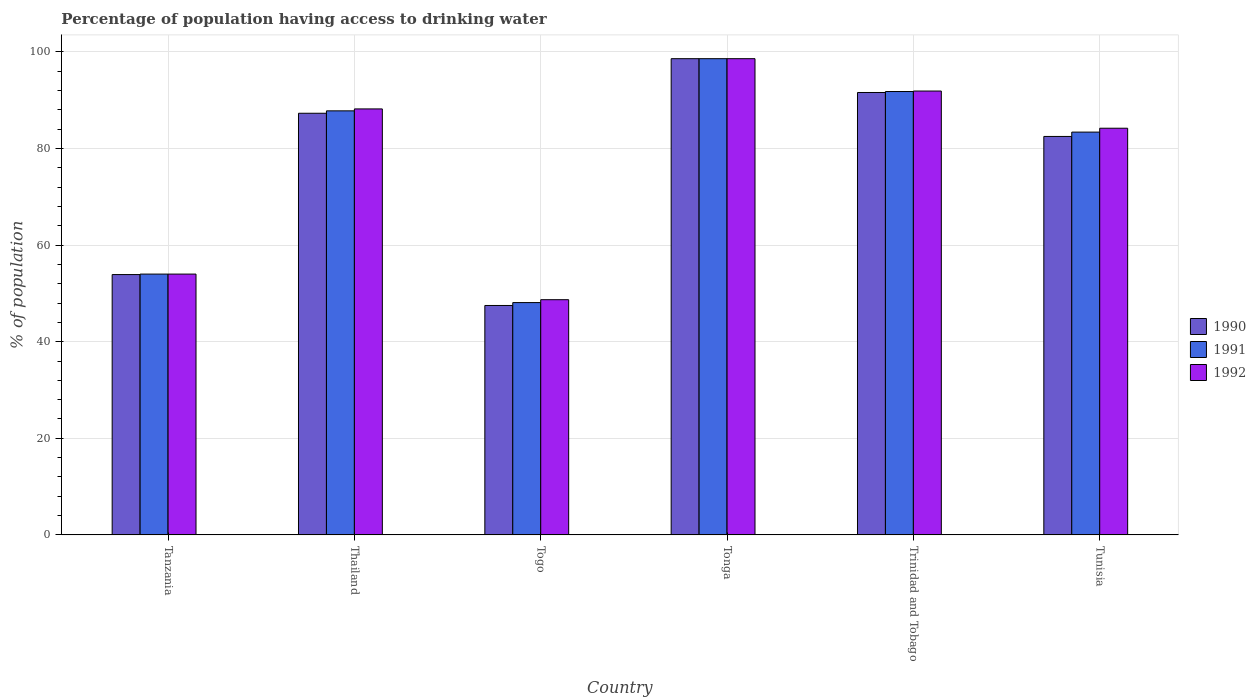How many different coloured bars are there?
Ensure brevity in your answer.  3. Are the number of bars per tick equal to the number of legend labels?
Ensure brevity in your answer.  Yes. Are the number of bars on each tick of the X-axis equal?
Offer a terse response. Yes. How many bars are there on the 2nd tick from the left?
Provide a succinct answer. 3. What is the label of the 3rd group of bars from the left?
Your answer should be compact. Togo. What is the percentage of population having access to drinking water in 1990 in Tanzania?
Provide a succinct answer. 53.9. Across all countries, what is the maximum percentage of population having access to drinking water in 1990?
Keep it short and to the point. 98.6. Across all countries, what is the minimum percentage of population having access to drinking water in 1991?
Provide a short and direct response. 48.1. In which country was the percentage of population having access to drinking water in 1991 maximum?
Make the answer very short. Tonga. In which country was the percentage of population having access to drinking water in 1992 minimum?
Make the answer very short. Togo. What is the total percentage of population having access to drinking water in 1992 in the graph?
Your answer should be very brief. 465.6. What is the difference between the percentage of population having access to drinking water in 1990 in Tanzania and that in Tunisia?
Ensure brevity in your answer.  -28.6. What is the difference between the percentage of population having access to drinking water in 1992 in Trinidad and Tobago and the percentage of population having access to drinking water in 1991 in Togo?
Offer a very short reply. 43.8. What is the average percentage of population having access to drinking water in 1990 per country?
Keep it short and to the point. 76.9. What is the difference between the percentage of population having access to drinking water of/in 1990 and percentage of population having access to drinking water of/in 1992 in Thailand?
Keep it short and to the point. -0.9. What is the ratio of the percentage of population having access to drinking water in 1992 in Trinidad and Tobago to that in Tunisia?
Your answer should be compact. 1.09. Is the percentage of population having access to drinking water in 1990 in Togo less than that in Tonga?
Give a very brief answer. Yes. What is the difference between the highest and the second highest percentage of population having access to drinking water in 1992?
Ensure brevity in your answer.  -10.4. What is the difference between the highest and the lowest percentage of population having access to drinking water in 1992?
Your response must be concise. 49.9. Is it the case that in every country, the sum of the percentage of population having access to drinking water in 1991 and percentage of population having access to drinking water in 1990 is greater than the percentage of population having access to drinking water in 1992?
Your answer should be compact. Yes. How many bars are there?
Provide a short and direct response. 18. Are all the bars in the graph horizontal?
Your answer should be compact. No. How many countries are there in the graph?
Your answer should be very brief. 6. Does the graph contain any zero values?
Provide a short and direct response. No. Where does the legend appear in the graph?
Your answer should be compact. Center right. How are the legend labels stacked?
Offer a terse response. Vertical. What is the title of the graph?
Offer a terse response. Percentage of population having access to drinking water. Does "1974" appear as one of the legend labels in the graph?
Your answer should be compact. No. What is the label or title of the X-axis?
Offer a very short reply. Country. What is the label or title of the Y-axis?
Keep it short and to the point. % of population. What is the % of population of 1990 in Tanzania?
Offer a terse response. 53.9. What is the % of population in 1990 in Thailand?
Provide a short and direct response. 87.3. What is the % of population of 1991 in Thailand?
Provide a short and direct response. 87.8. What is the % of population of 1992 in Thailand?
Ensure brevity in your answer.  88.2. What is the % of population in 1990 in Togo?
Your response must be concise. 47.5. What is the % of population of 1991 in Togo?
Make the answer very short. 48.1. What is the % of population of 1992 in Togo?
Offer a terse response. 48.7. What is the % of population in 1990 in Tonga?
Provide a succinct answer. 98.6. What is the % of population of 1991 in Tonga?
Offer a terse response. 98.6. What is the % of population of 1992 in Tonga?
Your answer should be compact. 98.6. What is the % of population of 1990 in Trinidad and Tobago?
Offer a terse response. 91.6. What is the % of population of 1991 in Trinidad and Tobago?
Give a very brief answer. 91.8. What is the % of population in 1992 in Trinidad and Tobago?
Your response must be concise. 91.9. What is the % of population of 1990 in Tunisia?
Ensure brevity in your answer.  82.5. What is the % of population in 1991 in Tunisia?
Your response must be concise. 83.4. What is the % of population in 1992 in Tunisia?
Your response must be concise. 84.2. Across all countries, what is the maximum % of population in 1990?
Provide a short and direct response. 98.6. Across all countries, what is the maximum % of population in 1991?
Make the answer very short. 98.6. Across all countries, what is the maximum % of population in 1992?
Ensure brevity in your answer.  98.6. Across all countries, what is the minimum % of population of 1990?
Your response must be concise. 47.5. Across all countries, what is the minimum % of population in 1991?
Keep it short and to the point. 48.1. Across all countries, what is the minimum % of population of 1992?
Keep it short and to the point. 48.7. What is the total % of population in 1990 in the graph?
Offer a very short reply. 461.4. What is the total % of population of 1991 in the graph?
Offer a very short reply. 463.7. What is the total % of population in 1992 in the graph?
Your answer should be compact. 465.6. What is the difference between the % of population in 1990 in Tanzania and that in Thailand?
Provide a short and direct response. -33.4. What is the difference between the % of population of 1991 in Tanzania and that in Thailand?
Your response must be concise. -33.8. What is the difference between the % of population of 1992 in Tanzania and that in Thailand?
Keep it short and to the point. -34.2. What is the difference between the % of population of 1990 in Tanzania and that in Togo?
Your answer should be very brief. 6.4. What is the difference between the % of population in 1991 in Tanzania and that in Togo?
Keep it short and to the point. 5.9. What is the difference between the % of population in 1992 in Tanzania and that in Togo?
Your answer should be very brief. 5.3. What is the difference between the % of population of 1990 in Tanzania and that in Tonga?
Offer a terse response. -44.7. What is the difference between the % of population of 1991 in Tanzania and that in Tonga?
Give a very brief answer. -44.6. What is the difference between the % of population of 1992 in Tanzania and that in Tonga?
Make the answer very short. -44.6. What is the difference between the % of population in 1990 in Tanzania and that in Trinidad and Tobago?
Your answer should be very brief. -37.7. What is the difference between the % of population in 1991 in Tanzania and that in Trinidad and Tobago?
Provide a short and direct response. -37.8. What is the difference between the % of population of 1992 in Tanzania and that in Trinidad and Tobago?
Make the answer very short. -37.9. What is the difference between the % of population of 1990 in Tanzania and that in Tunisia?
Ensure brevity in your answer.  -28.6. What is the difference between the % of population in 1991 in Tanzania and that in Tunisia?
Keep it short and to the point. -29.4. What is the difference between the % of population in 1992 in Tanzania and that in Tunisia?
Your answer should be compact. -30.2. What is the difference between the % of population in 1990 in Thailand and that in Togo?
Provide a succinct answer. 39.8. What is the difference between the % of population of 1991 in Thailand and that in Togo?
Give a very brief answer. 39.7. What is the difference between the % of population in 1992 in Thailand and that in Togo?
Your answer should be compact. 39.5. What is the difference between the % of population of 1990 in Thailand and that in Tonga?
Your answer should be very brief. -11.3. What is the difference between the % of population in 1991 in Thailand and that in Tonga?
Your answer should be compact. -10.8. What is the difference between the % of population in 1991 in Thailand and that in Trinidad and Tobago?
Provide a short and direct response. -4. What is the difference between the % of population in 1992 in Thailand and that in Trinidad and Tobago?
Keep it short and to the point. -3.7. What is the difference between the % of population of 1991 in Thailand and that in Tunisia?
Your response must be concise. 4.4. What is the difference between the % of population in 1992 in Thailand and that in Tunisia?
Make the answer very short. 4. What is the difference between the % of population of 1990 in Togo and that in Tonga?
Offer a very short reply. -51.1. What is the difference between the % of population of 1991 in Togo and that in Tonga?
Ensure brevity in your answer.  -50.5. What is the difference between the % of population in 1992 in Togo and that in Tonga?
Your response must be concise. -49.9. What is the difference between the % of population in 1990 in Togo and that in Trinidad and Tobago?
Provide a succinct answer. -44.1. What is the difference between the % of population of 1991 in Togo and that in Trinidad and Tobago?
Your response must be concise. -43.7. What is the difference between the % of population of 1992 in Togo and that in Trinidad and Tobago?
Your response must be concise. -43.2. What is the difference between the % of population of 1990 in Togo and that in Tunisia?
Your answer should be very brief. -35. What is the difference between the % of population in 1991 in Togo and that in Tunisia?
Provide a short and direct response. -35.3. What is the difference between the % of population in 1992 in Togo and that in Tunisia?
Keep it short and to the point. -35.5. What is the difference between the % of population of 1992 in Tonga and that in Tunisia?
Offer a very short reply. 14.4. What is the difference between the % of population of 1991 in Trinidad and Tobago and that in Tunisia?
Offer a terse response. 8.4. What is the difference between the % of population of 1992 in Trinidad and Tobago and that in Tunisia?
Your answer should be compact. 7.7. What is the difference between the % of population of 1990 in Tanzania and the % of population of 1991 in Thailand?
Your answer should be compact. -33.9. What is the difference between the % of population of 1990 in Tanzania and the % of population of 1992 in Thailand?
Give a very brief answer. -34.3. What is the difference between the % of population of 1991 in Tanzania and the % of population of 1992 in Thailand?
Offer a very short reply. -34.2. What is the difference between the % of population of 1991 in Tanzania and the % of population of 1992 in Togo?
Provide a succinct answer. 5.3. What is the difference between the % of population of 1990 in Tanzania and the % of population of 1991 in Tonga?
Offer a very short reply. -44.7. What is the difference between the % of population of 1990 in Tanzania and the % of population of 1992 in Tonga?
Your answer should be very brief. -44.7. What is the difference between the % of population in 1991 in Tanzania and the % of population in 1992 in Tonga?
Keep it short and to the point. -44.6. What is the difference between the % of population of 1990 in Tanzania and the % of population of 1991 in Trinidad and Tobago?
Give a very brief answer. -37.9. What is the difference between the % of population of 1990 in Tanzania and the % of population of 1992 in Trinidad and Tobago?
Ensure brevity in your answer.  -38. What is the difference between the % of population of 1991 in Tanzania and the % of population of 1992 in Trinidad and Tobago?
Make the answer very short. -37.9. What is the difference between the % of population of 1990 in Tanzania and the % of population of 1991 in Tunisia?
Provide a succinct answer. -29.5. What is the difference between the % of population of 1990 in Tanzania and the % of population of 1992 in Tunisia?
Ensure brevity in your answer.  -30.3. What is the difference between the % of population in 1991 in Tanzania and the % of population in 1992 in Tunisia?
Keep it short and to the point. -30.2. What is the difference between the % of population in 1990 in Thailand and the % of population in 1991 in Togo?
Provide a short and direct response. 39.2. What is the difference between the % of population in 1990 in Thailand and the % of population in 1992 in Togo?
Make the answer very short. 38.6. What is the difference between the % of population of 1991 in Thailand and the % of population of 1992 in Togo?
Provide a short and direct response. 39.1. What is the difference between the % of population of 1990 in Thailand and the % of population of 1991 in Trinidad and Tobago?
Offer a terse response. -4.5. What is the difference between the % of population of 1991 in Thailand and the % of population of 1992 in Trinidad and Tobago?
Your response must be concise. -4.1. What is the difference between the % of population of 1990 in Togo and the % of population of 1991 in Tonga?
Your response must be concise. -51.1. What is the difference between the % of population in 1990 in Togo and the % of population in 1992 in Tonga?
Provide a succinct answer. -51.1. What is the difference between the % of population of 1991 in Togo and the % of population of 1992 in Tonga?
Provide a short and direct response. -50.5. What is the difference between the % of population of 1990 in Togo and the % of population of 1991 in Trinidad and Tobago?
Make the answer very short. -44.3. What is the difference between the % of population in 1990 in Togo and the % of population in 1992 in Trinidad and Tobago?
Your response must be concise. -44.4. What is the difference between the % of population of 1991 in Togo and the % of population of 1992 in Trinidad and Tobago?
Give a very brief answer. -43.8. What is the difference between the % of population in 1990 in Togo and the % of population in 1991 in Tunisia?
Your answer should be very brief. -35.9. What is the difference between the % of population in 1990 in Togo and the % of population in 1992 in Tunisia?
Your response must be concise. -36.7. What is the difference between the % of population of 1991 in Togo and the % of population of 1992 in Tunisia?
Keep it short and to the point. -36.1. What is the difference between the % of population in 1990 in Tonga and the % of population in 1992 in Trinidad and Tobago?
Offer a very short reply. 6.7. What is the difference between the % of population in 1991 in Tonga and the % of population in 1992 in Trinidad and Tobago?
Give a very brief answer. 6.7. What is the difference between the % of population in 1990 in Tonga and the % of population in 1991 in Tunisia?
Your answer should be very brief. 15.2. What is the difference between the % of population in 1990 in Tonga and the % of population in 1992 in Tunisia?
Provide a short and direct response. 14.4. What is the difference between the % of population of 1991 in Tonga and the % of population of 1992 in Tunisia?
Offer a terse response. 14.4. What is the difference between the % of population of 1990 in Trinidad and Tobago and the % of population of 1991 in Tunisia?
Give a very brief answer. 8.2. What is the average % of population in 1990 per country?
Ensure brevity in your answer.  76.9. What is the average % of population of 1991 per country?
Keep it short and to the point. 77.28. What is the average % of population in 1992 per country?
Ensure brevity in your answer.  77.6. What is the difference between the % of population of 1991 and % of population of 1992 in Tanzania?
Make the answer very short. 0. What is the difference between the % of population of 1990 and % of population of 1991 in Thailand?
Your answer should be compact. -0.5. What is the difference between the % of population in 1990 and % of population in 1992 in Thailand?
Your answer should be compact. -0.9. What is the difference between the % of population in 1990 and % of population in 1992 in Togo?
Make the answer very short. -1.2. What is the difference between the % of population of 1990 and % of population of 1992 in Tonga?
Offer a terse response. 0. What is the difference between the % of population in 1990 and % of population in 1991 in Trinidad and Tobago?
Your answer should be compact. -0.2. What is the difference between the % of population of 1991 and % of population of 1992 in Trinidad and Tobago?
Make the answer very short. -0.1. What is the difference between the % of population of 1990 and % of population of 1991 in Tunisia?
Your answer should be compact. -0.9. What is the difference between the % of population of 1990 and % of population of 1992 in Tunisia?
Give a very brief answer. -1.7. What is the difference between the % of population in 1991 and % of population in 1992 in Tunisia?
Keep it short and to the point. -0.8. What is the ratio of the % of population in 1990 in Tanzania to that in Thailand?
Provide a short and direct response. 0.62. What is the ratio of the % of population in 1991 in Tanzania to that in Thailand?
Offer a terse response. 0.61. What is the ratio of the % of population in 1992 in Tanzania to that in Thailand?
Keep it short and to the point. 0.61. What is the ratio of the % of population in 1990 in Tanzania to that in Togo?
Your answer should be compact. 1.13. What is the ratio of the % of population of 1991 in Tanzania to that in Togo?
Provide a succinct answer. 1.12. What is the ratio of the % of population in 1992 in Tanzania to that in Togo?
Make the answer very short. 1.11. What is the ratio of the % of population in 1990 in Tanzania to that in Tonga?
Ensure brevity in your answer.  0.55. What is the ratio of the % of population of 1991 in Tanzania to that in Tonga?
Keep it short and to the point. 0.55. What is the ratio of the % of population of 1992 in Tanzania to that in Tonga?
Provide a succinct answer. 0.55. What is the ratio of the % of population in 1990 in Tanzania to that in Trinidad and Tobago?
Keep it short and to the point. 0.59. What is the ratio of the % of population of 1991 in Tanzania to that in Trinidad and Tobago?
Offer a terse response. 0.59. What is the ratio of the % of population in 1992 in Tanzania to that in Trinidad and Tobago?
Your answer should be compact. 0.59. What is the ratio of the % of population of 1990 in Tanzania to that in Tunisia?
Ensure brevity in your answer.  0.65. What is the ratio of the % of population in 1991 in Tanzania to that in Tunisia?
Offer a terse response. 0.65. What is the ratio of the % of population of 1992 in Tanzania to that in Tunisia?
Provide a succinct answer. 0.64. What is the ratio of the % of population of 1990 in Thailand to that in Togo?
Provide a succinct answer. 1.84. What is the ratio of the % of population in 1991 in Thailand to that in Togo?
Give a very brief answer. 1.83. What is the ratio of the % of population of 1992 in Thailand to that in Togo?
Offer a very short reply. 1.81. What is the ratio of the % of population of 1990 in Thailand to that in Tonga?
Provide a short and direct response. 0.89. What is the ratio of the % of population of 1991 in Thailand to that in Tonga?
Keep it short and to the point. 0.89. What is the ratio of the % of population in 1992 in Thailand to that in Tonga?
Keep it short and to the point. 0.89. What is the ratio of the % of population in 1990 in Thailand to that in Trinidad and Tobago?
Your answer should be very brief. 0.95. What is the ratio of the % of population in 1991 in Thailand to that in Trinidad and Tobago?
Give a very brief answer. 0.96. What is the ratio of the % of population of 1992 in Thailand to that in Trinidad and Tobago?
Ensure brevity in your answer.  0.96. What is the ratio of the % of population in 1990 in Thailand to that in Tunisia?
Ensure brevity in your answer.  1.06. What is the ratio of the % of population in 1991 in Thailand to that in Tunisia?
Make the answer very short. 1.05. What is the ratio of the % of population in 1992 in Thailand to that in Tunisia?
Provide a short and direct response. 1.05. What is the ratio of the % of population of 1990 in Togo to that in Tonga?
Offer a very short reply. 0.48. What is the ratio of the % of population of 1991 in Togo to that in Tonga?
Make the answer very short. 0.49. What is the ratio of the % of population of 1992 in Togo to that in Tonga?
Your answer should be very brief. 0.49. What is the ratio of the % of population in 1990 in Togo to that in Trinidad and Tobago?
Your answer should be compact. 0.52. What is the ratio of the % of population of 1991 in Togo to that in Trinidad and Tobago?
Your answer should be very brief. 0.52. What is the ratio of the % of population in 1992 in Togo to that in Trinidad and Tobago?
Make the answer very short. 0.53. What is the ratio of the % of population of 1990 in Togo to that in Tunisia?
Provide a succinct answer. 0.58. What is the ratio of the % of population of 1991 in Togo to that in Tunisia?
Keep it short and to the point. 0.58. What is the ratio of the % of population of 1992 in Togo to that in Tunisia?
Offer a terse response. 0.58. What is the ratio of the % of population in 1990 in Tonga to that in Trinidad and Tobago?
Ensure brevity in your answer.  1.08. What is the ratio of the % of population in 1991 in Tonga to that in Trinidad and Tobago?
Your answer should be very brief. 1.07. What is the ratio of the % of population in 1992 in Tonga to that in Trinidad and Tobago?
Your answer should be very brief. 1.07. What is the ratio of the % of population of 1990 in Tonga to that in Tunisia?
Your response must be concise. 1.2. What is the ratio of the % of population in 1991 in Tonga to that in Tunisia?
Your response must be concise. 1.18. What is the ratio of the % of population of 1992 in Tonga to that in Tunisia?
Keep it short and to the point. 1.17. What is the ratio of the % of population in 1990 in Trinidad and Tobago to that in Tunisia?
Your answer should be very brief. 1.11. What is the ratio of the % of population in 1991 in Trinidad and Tobago to that in Tunisia?
Offer a terse response. 1.1. What is the ratio of the % of population of 1992 in Trinidad and Tobago to that in Tunisia?
Offer a very short reply. 1.09. What is the difference between the highest and the second highest % of population of 1990?
Provide a succinct answer. 7. What is the difference between the highest and the second highest % of population of 1991?
Ensure brevity in your answer.  6.8. What is the difference between the highest and the lowest % of population of 1990?
Your answer should be compact. 51.1. What is the difference between the highest and the lowest % of population of 1991?
Make the answer very short. 50.5. What is the difference between the highest and the lowest % of population in 1992?
Offer a very short reply. 49.9. 